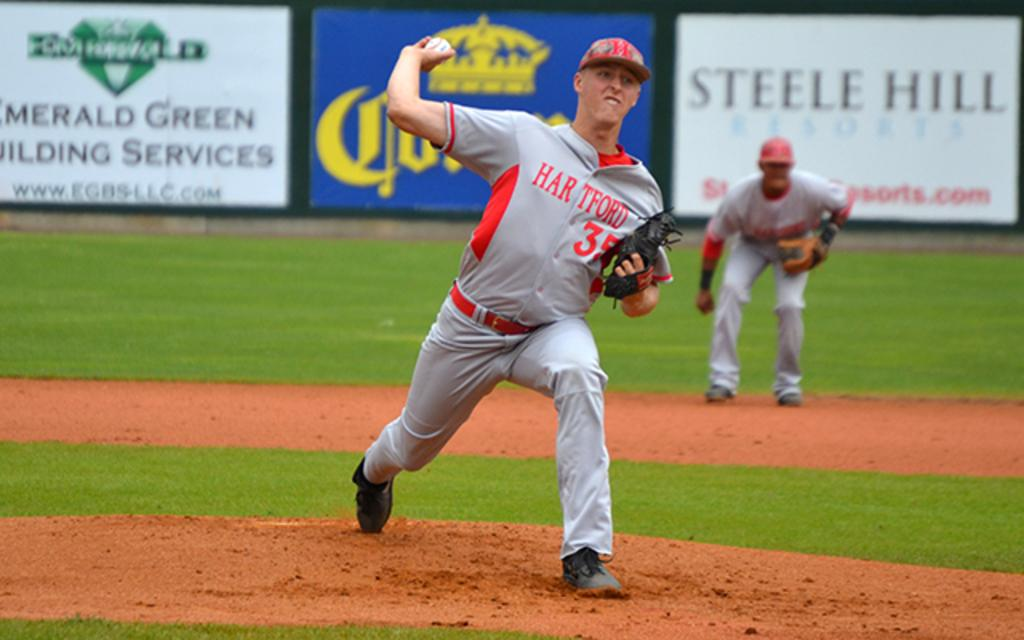<image>
Provide a brief description of the given image. Baseball player wearing number 35 pitching the baseball. 